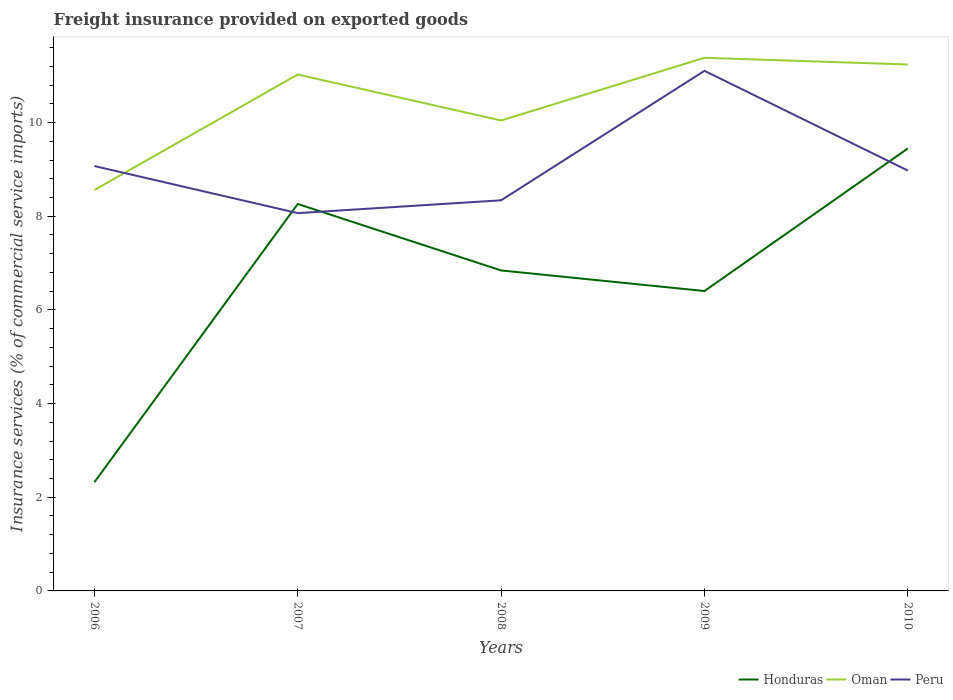Does the line corresponding to Honduras intersect with the line corresponding to Oman?
Your answer should be very brief. No. Across all years, what is the maximum freight insurance provided on exported goods in Honduras?
Make the answer very short. 2.32. What is the total freight insurance provided on exported goods in Honduras in the graph?
Your response must be concise. -2.6. What is the difference between the highest and the second highest freight insurance provided on exported goods in Peru?
Offer a very short reply. 3.04. How many lines are there?
Make the answer very short. 3. Are the values on the major ticks of Y-axis written in scientific E-notation?
Make the answer very short. No. How are the legend labels stacked?
Give a very brief answer. Horizontal. What is the title of the graph?
Provide a short and direct response. Freight insurance provided on exported goods. What is the label or title of the X-axis?
Provide a succinct answer. Years. What is the label or title of the Y-axis?
Your answer should be very brief. Insurance services (% of commercial service imports). What is the Insurance services (% of commercial service imports) in Honduras in 2006?
Provide a succinct answer. 2.32. What is the Insurance services (% of commercial service imports) in Oman in 2006?
Your answer should be very brief. 8.56. What is the Insurance services (% of commercial service imports) of Peru in 2006?
Your answer should be compact. 9.07. What is the Insurance services (% of commercial service imports) in Honduras in 2007?
Your response must be concise. 8.26. What is the Insurance services (% of commercial service imports) in Oman in 2007?
Ensure brevity in your answer.  11.03. What is the Insurance services (% of commercial service imports) in Peru in 2007?
Give a very brief answer. 8.07. What is the Insurance services (% of commercial service imports) of Honduras in 2008?
Give a very brief answer. 6.84. What is the Insurance services (% of commercial service imports) of Oman in 2008?
Provide a succinct answer. 10.04. What is the Insurance services (% of commercial service imports) in Peru in 2008?
Your answer should be compact. 8.34. What is the Insurance services (% of commercial service imports) of Honduras in 2009?
Offer a very short reply. 6.4. What is the Insurance services (% of commercial service imports) of Oman in 2009?
Make the answer very short. 11.38. What is the Insurance services (% of commercial service imports) in Peru in 2009?
Make the answer very short. 11.1. What is the Insurance services (% of commercial service imports) of Honduras in 2010?
Your answer should be very brief. 9.45. What is the Insurance services (% of commercial service imports) in Oman in 2010?
Offer a terse response. 11.24. What is the Insurance services (% of commercial service imports) of Peru in 2010?
Give a very brief answer. 8.98. Across all years, what is the maximum Insurance services (% of commercial service imports) of Honduras?
Make the answer very short. 9.45. Across all years, what is the maximum Insurance services (% of commercial service imports) in Oman?
Offer a terse response. 11.38. Across all years, what is the maximum Insurance services (% of commercial service imports) in Peru?
Your answer should be compact. 11.1. Across all years, what is the minimum Insurance services (% of commercial service imports) of Honduras?
Make the answer very short. 2.32. Across all years, what is the minimum Insurance services (% of commercial service imports) of Oman?
Keep it short and to the point. 8.56. Across all years, what is the minimum Insurance services (% of commercial service imports) in Peru?
Ensure brevity in your answer.  8.07. What is the total Insurance services (% of commercial service imports) in Honduras in the graph?
Keep it short and to the point. 33.28. What is the total Insurance services (% of commercial service imports) in Oman in the graph?
Your response must be concise. 52.25. What is the total Insurance services (% of commercial service imports) of Peru in the graph?
Make the answer very short. 45.56. What is the difference between the Insurance services (% of commercial service imports) in Honduras in 2006 and that in 2007?
Offer a terse response. -5.94. What is the difference between the Insurance services (% of commercial service imports) of Oman in 2006 and that in 2007?
Make the answer very short. -2.47. What is the difference between the Insurance services (% of commercial service imports) in Peru in 2006 and that in 2007?
Make the answer very short. 1.01. What is the difference between the Insurance services (% of commercial service imports) in Honduras in 2006 and that in 2008?
Make the answer very short. -4.52. What is the difference between the Insurance services (% of commercial service imports) in Oman in 2006 and that in 2008?
Make the answer very short. -1.48. What is the difference between the Insurance services (% of commercial service imports) of Peru in 2006 and that in 2008?
Ensure brevity in your answer.  0.73. What is the difference between the Insurance services (% of commercial service imports) of Honduras in 2006 and that in 2009?
Your answer should be compact. -4.08. What is the difference between the Insurance services (% of commercial service imports) in Oman in 2006 and that in 2009?
Give a very brief answer. -2.82. What is the difference between the Insurance services (% of commercial service imports) in Peru in 2006 and that in 2009?
Your response must be concise. -2.03. What is the difference between the Insurance services (% of commercial service imports) in Honduras in 2006 and that in 2010?
Your answer should be compact. -7.13. What is the difference between the Insurance services (% of commercial service imports) of Oman in 2006 and that in 2010?
Offer a very short reply. -2.68. What is the difference between the Insurance services (% of commercial service imports) in Peru in 2006 and that in 2010?
Keep it short and to the point. 0.1. What is the difference between the Insurance services (% of commercial service imports) in Honduras in 2007 and that in 2008?
Your answer should be very brief. 1.42. What is the difference between the Insurance services (% of commercial service imports) in Oman in 2007 and that in 2008?
Ensure brevity in your answer.  0.98. What is the difference between the Insurance services (% of commercial service imports) in Peru in 2007 and that in 2008?
Offer a terse response. -0.27. What is the difference between the Insurance services (% of commercial service imports) of Honduras in 2007 and that in 2009?
Offer a terse response. 1.86. What is the difference between the Insurance services (% of commercial service imports) of Oman in 2007 and that in 2009?
Your answer should be very brief. -0.36. What is the difference between the Insurance services (% of commercial service imports) of Peru in 2007 and that in 2009?
Give a very brief answer. -3.04. What is the difference between the Insurance services (% of commercial service imports) in Honduras in 2007 and that in 2010?
Your response must be concise. -1.18. What is the difference between the Insurance services (% of commercial service imports) of Oman in 2007 and that in 2010?
Ensure brevity in your answer.  -0.21. What is the difference between the Insurance services (% of commercial service imports) in Peru in 2007 and that in 2010?
Provide a succinct answer. -0.91. What is the difference between the Insurance services (% of commercial service imports) in Honduras in 2008 and that in 2009?
Offer a terse response. 0.44. What is the difference between the Insurance services (% of commercial service imports) of Oman in 2008 and that in 2009?
Make the answer very short. -1.34. What is the difference between the Insurance services (% of commercial service imports) of Peru in 2008 and that in 2009?
Give a very brief answer. -2.76. What is the difference between the Insurance services (% of commercial service imports) in Honduras in 2008 and that in 2010?
Offer a terse response. -2.6. What is the difference between the Insurance services (% of commercial service imports) of Oman in 2008 and that in 2010?
Ensure brevity in your answer.  -1.2. What is the difference between the Insurance services (% of commercial service imports) of Peru in 2008 and that in 2010?
Offer a very short reply. -0.63. What is the difference between the Insurance services (% of commercial service imports) of Honduras in 2009 and that in 2010?
Your response must be concise. -3.04. What is the difference between the Insurance services (% of commercial service imports) in Oman in 2009 and that in 2010?
Ensure brevity in your answer.  0.14. What is the difference between the Insurance services (% of commercial service imports) of Peru in 2009 and that in 2010?
Make the answer very short. 2.13. What is the difference between the Insurance services (% of commercial service imports) of Honduras in 2006 and the Insurance services (% of commercial service imports) of Oman in 2007?
Keep it short and to the point. -8.71. What is the difference between the Insurance services (% of commercial service imports) of Honduras in 2006 and the Insurance services (% of commercial service imports) of Peru in 2007?
Ensure brevity in your answer.  -5.75. What is the difference between the Insurance services (% of commercial service imports) in Oman in 2006 and the Insurance services (% of commercial service imports) in Peru in 2007?
Provide a succinct answer. 0.49. What is the difference between the Insurance services (% of commercial service imports) of Honduras in 2006 and the Insurance services (% of commercial service imports) of Oman in 2008?
Make the answer very short. -7.72. What is the difference between the Insurance services (% of commercial service imports) in Honduras in 2006 and the Insurance services (% of commercial service imports) in Peru in 2008?
Your answer should be very brief. -6.02. What is the difference between the Insurance services (% of commercial service imports) in Oman in 2006 and the Insurance services (% of commercial service imports) in Peru in 2008?
Offer a terse response. 0.22. What is the difference between the Insurance services (% of commercial service imports) of Honduras in 2006 and the Insurance services (% of commercial service imports) of Oman in 2009?
Your answer should be compact. -9.06. What is the difference between the Insurance services (% of commercial service imports) in Honduras in 2006 and the Insurance services (% of commercial service imports) in Peru in 2009?
Offer a very short reply. -8.78. What is the difference between the Insurance services (% of commercial service imports) in Oman in 2006 and the Insurance services (% of commercial service imports) in Peru in 2009?
Your response must be concise. -2.54. What is the difference between the Insurance services (% of commercial service imports) in Honduras in 2006 and the Insurance services (% of commercial service imports) in Oman in 2010?
Your answer should be very brief. -8.92. What is the difference between the Insurance services (% of commercial service imports) of Honduras in 2006 and the Insurance services (% of commercial service imports) of Peru in 2010?
Your answer should be compact. -6.65. What is the difference between the Insurance services (% of commercial service imports) of Oman in 2006 and the Insurance services (% of commercial service imports) of Peru in 2010?
Offer a very short reply. -0.42. What is the difference between the Insurance services (% of commercial service imports) in Honduras in 2007 and the Insurance services (% of commercial service imports) in Oman in 2008?
Provide a short and direct response. -1.78. What is the difference between the Insurance services (% of commercial service imports) in Honduras in 2007 and the Insurance services (% of commercial service imports) in Peru in 2008?
Offer a very short reply. -0.08. What is the difference between the Insurance services (% of commercial service imports) of Oman in 2007 and the Insurance services (% of commercial service imports) of Peru in 2008?
Offer a very short reply. 2.69. What is the difference between the Insurance services (% of commercial service imports) in Honduras in 2007 and the Insurance services (% of commercial service imports) in Oman in 2009?
Give a very brief answer. -3.12. What is the difference between the Insurance services (% of commercial service imports) in Honduras in 2007 and the Insurance services (% of commercial service imports) in Peru in 2009?
Your answer should be compact. -2.84. What is the difference between the Insurance services (% of commercial service imports) in Oman in 2007 and the Insurance services (% of commercial service imports) in Peru in 2009?
Offer a very short reply. -0.08. What is the difference between the Insurance services (% of commercial service imports) of Honduras in 2007 and the Insurance services (% of commercial service imports) of Oman in 2010?
Offer a very short reply. -2.98. What is the difference between the Insurance services (% of commercial service imports) of Honduras in 2007 and the Insurance services (% of commercial service imports) of Peru in 2010?
Offer a very short reply. -0.71. What is the difference between the Insurance services (% of commercial service imports) in Oman in 2007 and the Insurance services (% of commercial service imports) in Peru in 2010?
Your answer should be compact. 2.05. What is the difference between the Insurance services (% of commercial service imports) in Honduras in 2008 and the Insurance services (% of commercial service imports) in Oman in 2009?
Keep it short and to the point. -4.54. What is the difference between the Insurance services (% of commercial service imports) of Honduras in 2008 and the Insurance services (% of commercial service imports) of Peru in 2009?
Make the answer very short. -4.26. What is the difference between the Insurance services (% of commercial service imports) of Oman in 2008 and the Insurance services (% of commercial service imports) of Peru in 2009?
Ensure brevity in your answer.  -1.06. What is the difference between the Insurance services (% of commercial service imports) of Honduras in 2008 and the Insurance services (% of commercial service imports) of Oman in 2010?
Make the answer very short. -4.4. What is the difference between the Insurance services (% of commercial service imports) in Honduras in 2008 and the Insurance services (% of commercial service imports) in Peru in 2010?
Offer a very short reply. -2.13. What is the difference between the Insurance services (% of commercial service imports) of Oman in 2008 and the Insurance services (% of commercial service imports) of Peru in 2010?
Offer a terse response. 1.07. What is the difference between the Insurance services (% of commercial service imports) of Honduras in 2009 and the Insurance services (% of commercial service imports) of Oman in 2010?
Your answer should be very brief. -4.84. What is the difference between the Insurance services (% of commercial service imports) of Honduras in 2009 and the Insurance services (% of commercial service imports) of Peru in 2010?
Provide a succinct answer. -2.57. What is the difference between the Insurance services (% of commercial service imports) in Oman in 2009 and the Insurance services (% of commercial service imports) in Peru in 2010?
Keep it short and to the point. 2.41. What is the average Insurance services (% of commercial service imports) of Honduras per year?
Make the answer very short. 6.66. What is the average Insurance services (% of commercial service imports) of Oman per year?
Make the answer very short. 10.45. What is the average Insurance services (% of commercial service imports) in Peru per year?
Your response must be concise. 9.11. In the year 2006, what is the difference between the Insurance services (% of commercial service imports) in Honduras and Insurance services (% of commercial service imports) in Oman?
Provide a succinct answer. -6.24. In the year 2006, what is the difference between the Insurance services (% of commercial service imports) of Honduras and Insurance services (% of commercial service imports) of Peru?
Ensure brevity in your answer.  -6.75. In the year 2006, what is the difference between the Insurance services (% of commercial service imports) in Oman and Insurance services (% of commercial service imports) in Peru?
Keep it short and to the point. -0.51. In the year 2007, what is the difference between the Insurance services (% of commercial service imports) in Honduras and Insurance services (% of commercial service imports) in Oman?
Provide a short and direct response. -2.76. In the year 2007, what is the difference between the Insurance services (% of commercial service imports) of Honduras and Insurance services (% of commercial service imports) of Peru?
Your answer should be compact. 0.2. In the year 2007, what is the difference between the Insurance services (% of commercial service imports) of Oman and Insurance services (% of commercial service imports) of Peru?
Your response must be concise. 2.96. In the year 2008, what is the difference between the Insurance services (% of commercial service imports) of Honduras and Insurance services (% of commercial service imports) of Oman?
Keep it short and to the point. -3.2. In the year 2008, what is the difference between the Insurance services (% of commercial service imports) of Honduras and Insurance services (% of commercial service imports) of Peru?
Make the answer very short. -1.5. In the year 2008, what is the difference between the Insurance services (% of commercial service imports) in Oman and Insurance services (% of commercial service imports) in Peru?
Your answer should be very brief. 1.7. In the year 2009, what is the difference between the Insurance services (% of commercial service imports) of Honduras and Insurance services (% of commercial service imports) of Oman?
Provide a succinct answer. -4.98. In the year 2009, what is the difference between the Insurance services (% of commercial service imports) in Honduras and Insurance services (% of commercial service imports) in Peru?
Offer a terse response. -4.7. In the year 2009, what is the difference between the Insurance services (% of commercial service imports) in Oman and Insurance services (% of commercial service imports) in Peru?
Provide a short and direct response. 0.28. In the year 2010, what is the difference between the Insurance services (% of commercial service imports) of Honduras and Insurance services (% of commercial service imports) of Oman?
Your response must be concise. -1.79. In the year 2010, what is the difference between the Insurance services (% of commercial service imports) in Honduras and Insurance services (% of commercial service imports) in Peru?
Keep it short and to the point. 0.47. In the year 2010, what is the difference between the Insurance services (% of commercial service imports) in Oman and Insurance services (% of commercial service imports) in Peru?
Provide a short and direct response. 2.26. What is the ratio of the Insurance services (% of commercial service imports) of Honduras in 2006 to that in 2007?
Your response must be concise. 0.28. What is the ratio of the Insurance services (% of commercial service imports) of Oman in 2006 to that in 2007?
Provide a succinct answer. 0.78. What is the ratio of the Insurance services (% of commercial service imports) in Peru in 2006 to that in 2007?
Your response must be concise. 1.12. What is the ratio of the Insurance services (% of commercial service imports) in Honduras in 2006 to that in 2008?
Provide a short and direct response. 0.34. What is the ratio of the Insurance services (% of commercial service imports) in Oman in 2006 to that in 2008?
Make the answer very short. 0.85. What is the ratio of the Insurance services (% of commercial service imports) in Peru in 2006 to that in 2008?
Keep it short and to the point. 1.09. What is the ratio of the Insurance services (% of commercial service imports) in Honduras in 2006 to that in 2009?
Offer a terse response. 0.36. What is the ratio of the Insurance services (% of commercial service imports) in Oman in 2006 to that in 2009?
Give a very brief answer. 0.75. What is the ratio of the Insurance services (% of commercial service imports) in Peru in 2006 to that in 2009?
Your answer should be compact. 0.82. What is the ratio of the Insurance services (% of commercial service imports) of Honduras in 2006 to that in 2010?
Offer a terse response. 0.25. What is the ratio of the Insurance services (% of commercial service imports) of Oman in 2006 to that in 2010?
Your answer should be very brief. 0.76. What is the ratio of the Insurance services (% of commercial service imports) in Peru in 2006 to that in 2010?
Provide a short and direct response. 1.01. What is the ratio of the Insurance services (% of commercial service imports) of Honduras in 2007 to that in 2008?
Provide a short and direct response. 1.21. What is the ratio of the Insurance services (% of commercial service imports) in Oman in 2007 to that in 2008?
Your answer should be compact. 1.1. What is the ratio of the Insurance services (% of commercial service imports) of Peru in 2007 to that in 2008?
Make the answer very short. 0.97. What is the ratio of the Insurance services (% of commercial service imports) of Honduras in 2007 to that in 2009?
Your answer should be very brief. 1.29. What is the ratio of the Insurance services (% of commercial service imports) of Oman in 2007 to that in 2009?
Keep it short and to the point. 0.97. What is the ratio of the Insurance services (% of commercial service imports) in Peru in 2007 to that in 2009?
Give a very brief answer. 0.73. What is the ratio of the Insurance services (% of commercial service imports) of Honduras in 2007 to that in 2010?
Provide a short and direct response. 0.87. What is the ratio of the Insurance services (% of commercial service imports) in Peru in 2007 to that in 2010?
Offer a very short reply. 0.9. What is the ratio of the Insurance services (% of commercial service imports) of Honduras in 2008 to that in 2009?
Make the answer very short. 1.07. What is the ratio of the Insurance services (% of commercial service imports) in Oman in 2008 to that in 2009?
Provide a short and direct response. 0.88. What is the ratio of the Insurance services (% of commercial service imports) in Peru in 2008 to that in 2009?
Your answer should be compact. 0.75. What is the ratio of the Insurance services (% of commercial service imports) of Honduras in 2008 to that in 2010?
Provide a short and direct response. 0.72. What is the ratio of the Insurance services (% of commercial service imports) in Oman in 2008 to that in 2010?
Offer a very short reply. 0.89. What is the ratio of the Insurance services (% of commercial service imports) of Peru in 2008 to that in 2010?
Offer a terse response. 0.93. What is the ratio of the Insurance services (% of commercial service imports) of Honduras in 2009 to that in 2010?
Offer a very short reply. 0.68. What is the ratio of the Insurance services (% of commercial service imports) in Oman in 2009 to that in 2010?
Your answer should be compact. 1.01. What is the ratio of the Insurance services (% of commercial service imports) in Peru in 2009 to that in 2010?
Keep it short and to the point. 1.24. What is the difference between the highest and the second highest Insurance services (% of commercial service imports) of Honduras?
Make the answer very short. 1.18. What is the difference between the highest and the second highest Insurance services (% of commercial service imports) in Oman?
Offer a terse response. 0.14. What is the difference between the highest and the second highest Insurance services (% of commercial service imports) of Peru?
Ensure brevity in your answer.  2.03. What is the difference between the highest and the lowest Insurance services (% of commercial service imports) of Honduras?
Offer a very short reply. 7.13. What is the difference between the highest and the lowest Insurance services (% of commercial service imports) in Oman?
Offer a very short reply. 2.82. What is the difference between the highest and the lowest Insurance services (% of commercial service imports) of Peru?
Ensure brevity in your answer.  3.04. 